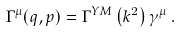<formula> <loc_0><loc_0><loc_500><loc_500>\Gamma ^ { \mu } ( q , p ) = \Gamma ^ { Y M } \left ( k ^ { 2 } \right ) \gamma ^ { \mu } \, .</formula> 